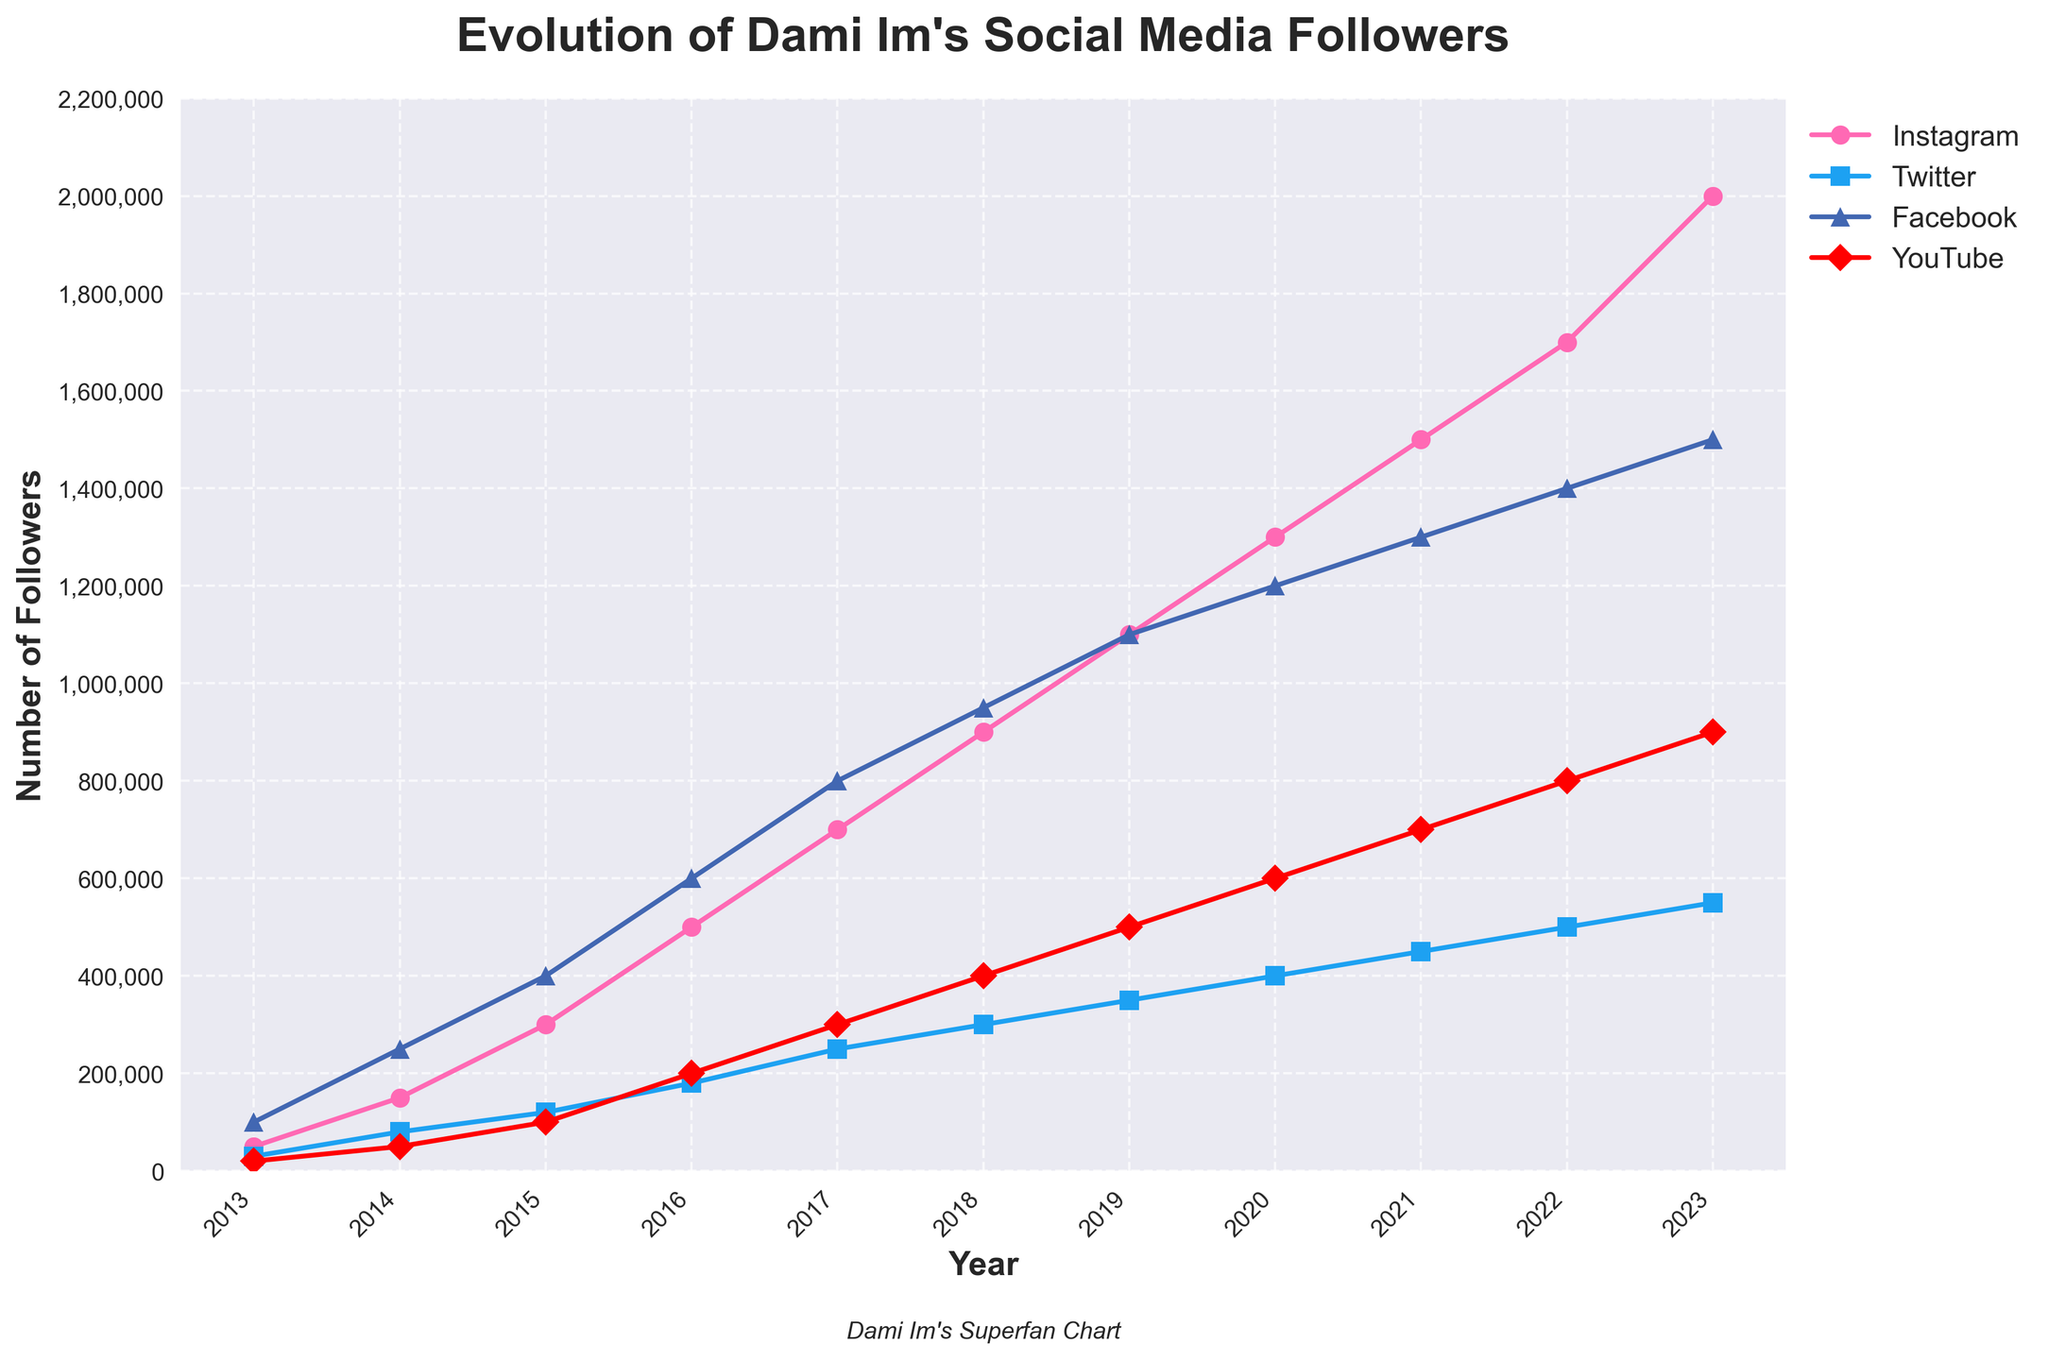Which year did Dami Im's Instagram followers surpass 1 million for the first time? To identify the year Instagram surpassed 1 million followers, look at the Instagram curve and find the point where it crosses 1 million on the y-axis.
Answer: 2019 Which social media platform had the highest number of followers in 2020? Look at the year 2020 and compare the follower counts across Instagram, Twitter, Facebook, and YouTube. The platform with the tallest vertical position has the highest follower count.
Answer: Instagram What's the combined total of Twitter and YouTube followers for the year 2022? Find the follower counts for Twitter and YouTube in 2022. Sum them up: 500,000 (Twitter) + 800,000 (YouTube) = 1,300,000.
Answer: 1,300,000 In which year did Facebook have 800,000 followers? Locate the year where the Facebook curve intersects the 800,000 mark on the y-axis.
Answer: 2017 How many followers did Dami Im gain on Instagram from 2014 to 2015? Subtract the number of Instagram followers in 2014 from the number in 2015: 300,000 (2015) - 150,000 (2014) = 150,000.
Answer: 150,000 Which platform showed the most significant growth in followers from 2013 to 2023? Compare the difference between starting and ending positions on the y-axis for each platform. Instagram's growth is from 50,000 to 2,000,000, making it the most significant.
Answer: Instagram By how much did Dami Im's YouTube followers increase between 2015 and 2020? Subtract the YouTube followers in 2015 from those in 2020: 600,000 (2020) - 100,000 (2015) = 500,000.
Answer: 500,000 Which platform had the slowest growth rate from 2016 to 2021? Observe the slopes of the lines from 2016 to 2021. Twitter has the most gradual increase with a rise of just about 270,000 followers (180,000 to 450,000).
Answer: Twitter Are there any years where Facebook and Instagram had the same number of followers? Examine the intersection points of the Facebook and Instagram lines. There are no points where they intersect.
Answer: No What's the average number of Twitter followers over the entire period from 2013 to 2023? Add up the Twitter followers for each year and divide by the number of years: (30,000 + 80,000 + 120,000 + 180,000 + 250,000 + 300,000 + 350,000 + 400,000 + 450,000 + 500,000 + 550,000) / 11 = 291,818 (approx).
Answer: 291,818 